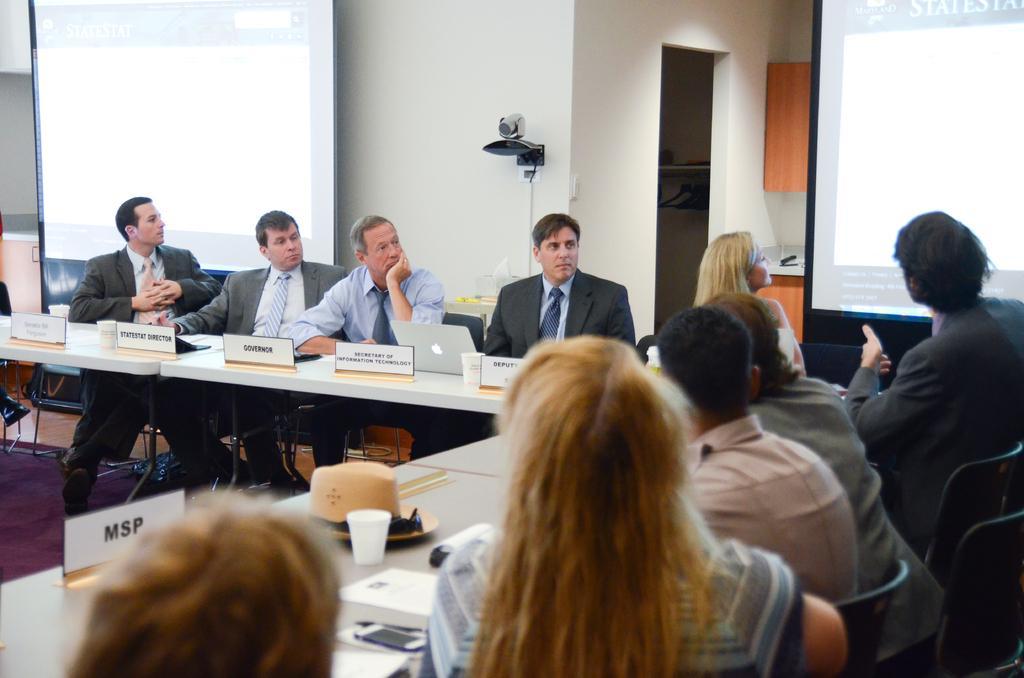How would you summarize this image in a sentence or two? In the image few people are sitting on chairs and there is a table on the table there are some laptops, cups, hat, mobile phone, Papers. Behind them there is a wall. Top left side of the image there is a screen. Top right side of the image there is a screen. 